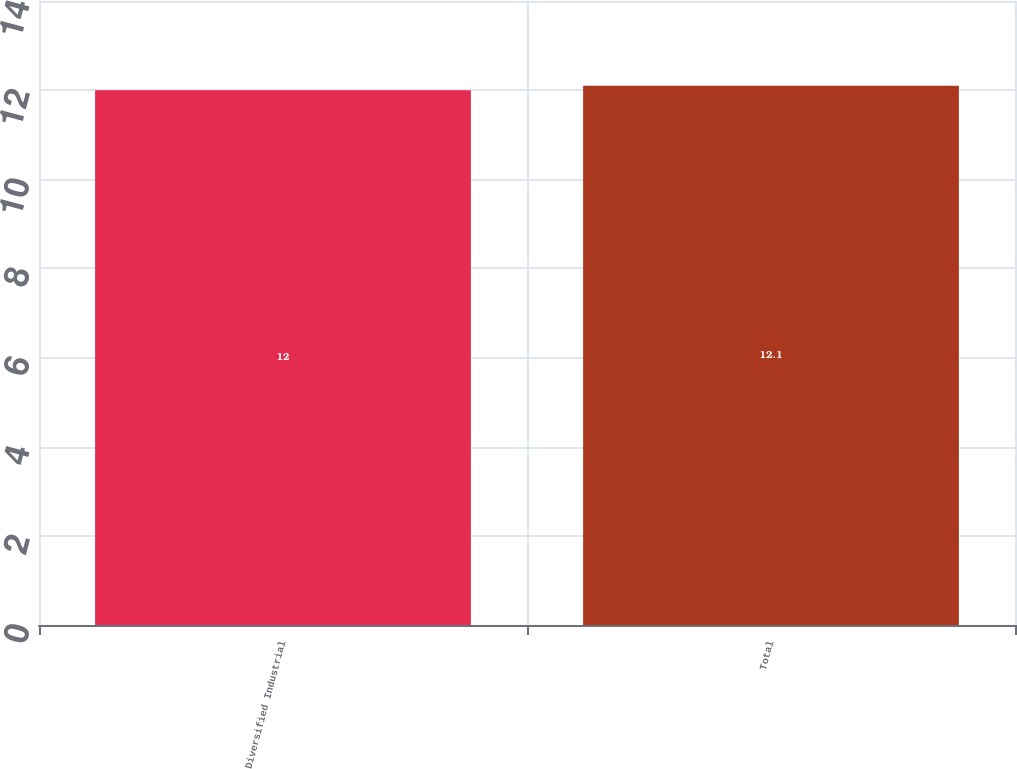<chart> <loc_0><loc_0><loc_500><loc_500><bar_chart><fcel>Diversified Industrial<fcel>Total<nl><fcel>12<fcel>12.1<nl></chart> 